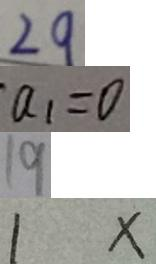<formula> <loc_0><loc_0><loc_500><loc_500>2 9 
 a _ { 1 } = 0 
 1 9 
 1 x</formula> 